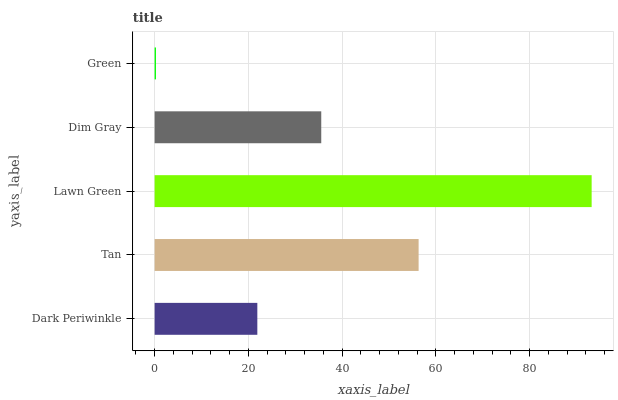Is Green the minimum?
Answer yes or no. Yes. Is Lawn Green the maximum?
Answer yes or no. Yes. Is Tan the minimum?
Answer yes or no. No. Is Tan the maximum?
Answer yes or no. No. Is Tan greater than Dark Periwinkle?
Answer yes or no. Yes. Is Dark Periwinkle less than Tan?
Answer yes or no. Yes. Is Dark Periwinkle greater than Tan?
Answer yes or no. No. Is Tan less than Dark Periwinkle?
Answer yes or no. No. Is Dim Gray the high median?
Answer yes or no. Yes. Is Dim Gray the low median?
Answer yes or no. Yes. Is Tan the high median?
Answer yes or no. No. Is Dark Periwinkle the low median?
Answer yes or no. No. 